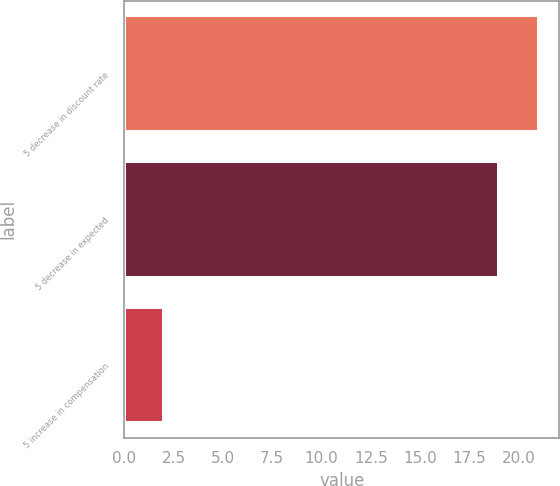Convert chart. <chart><loc_0><loc_0><loc_500><loc_500><bar_chart><fcel>5 decrease in discount rate<fcel>5 decrease in expected<fcel>5 increase in compensation<nl><fcel>21<fcel>19<fcel>2<nl></chart> 